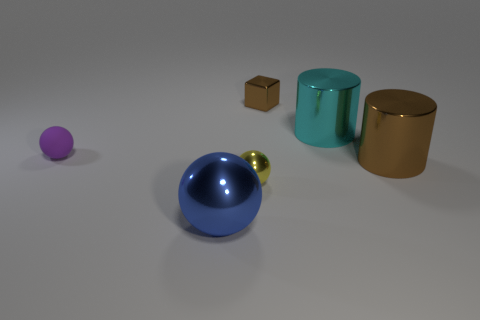There is a brown thing that is the same material as the tiny block; what shape is it?
Provide a short and direct response. Cylinder. Is the size of the shiny cylinder in front of the purple rubber sphere the same as the blue sphere?
Your answer should be very brief. Yes. Are there fewer blue metallic spheres than large yellow rubber balls?
Your response must be concise. No. Are there any yellow blocks made of the same material as the big blue sphere?
Your response must be concise. No. What shape is the big metallic object that is to the left of the small block?
Your answer should be compact. Sphere. There is a cylinder that is on the right side of the big cyan shiny cylinder; is it the same color as the small metal sphere?
Offer a terse response. No. Is the number of tiny brown metallic things to the right of the small metal cube less than the number of small yellow shiny objects?
Your answer should be compact. Yes. What is the color of the small block that is made of the same material as the small yellow sphere?
Your answer should be very brief. Brown. What is the size of the brown thing that is in front of the brown cube?
Provide a succinct answer. Large. Is the material of the block the same as the purple thing?
Offer a terse response. No. 